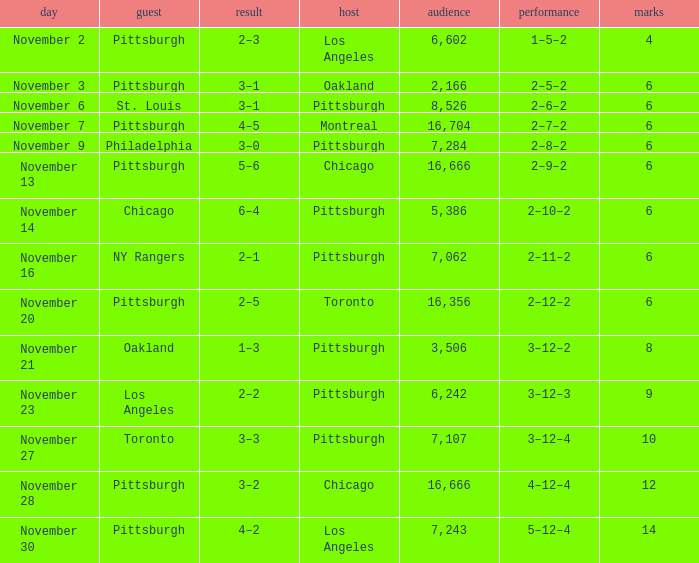What is the sum of the points of the game with philadelphia as the visitor and an attendance greater than 7,284? None. 